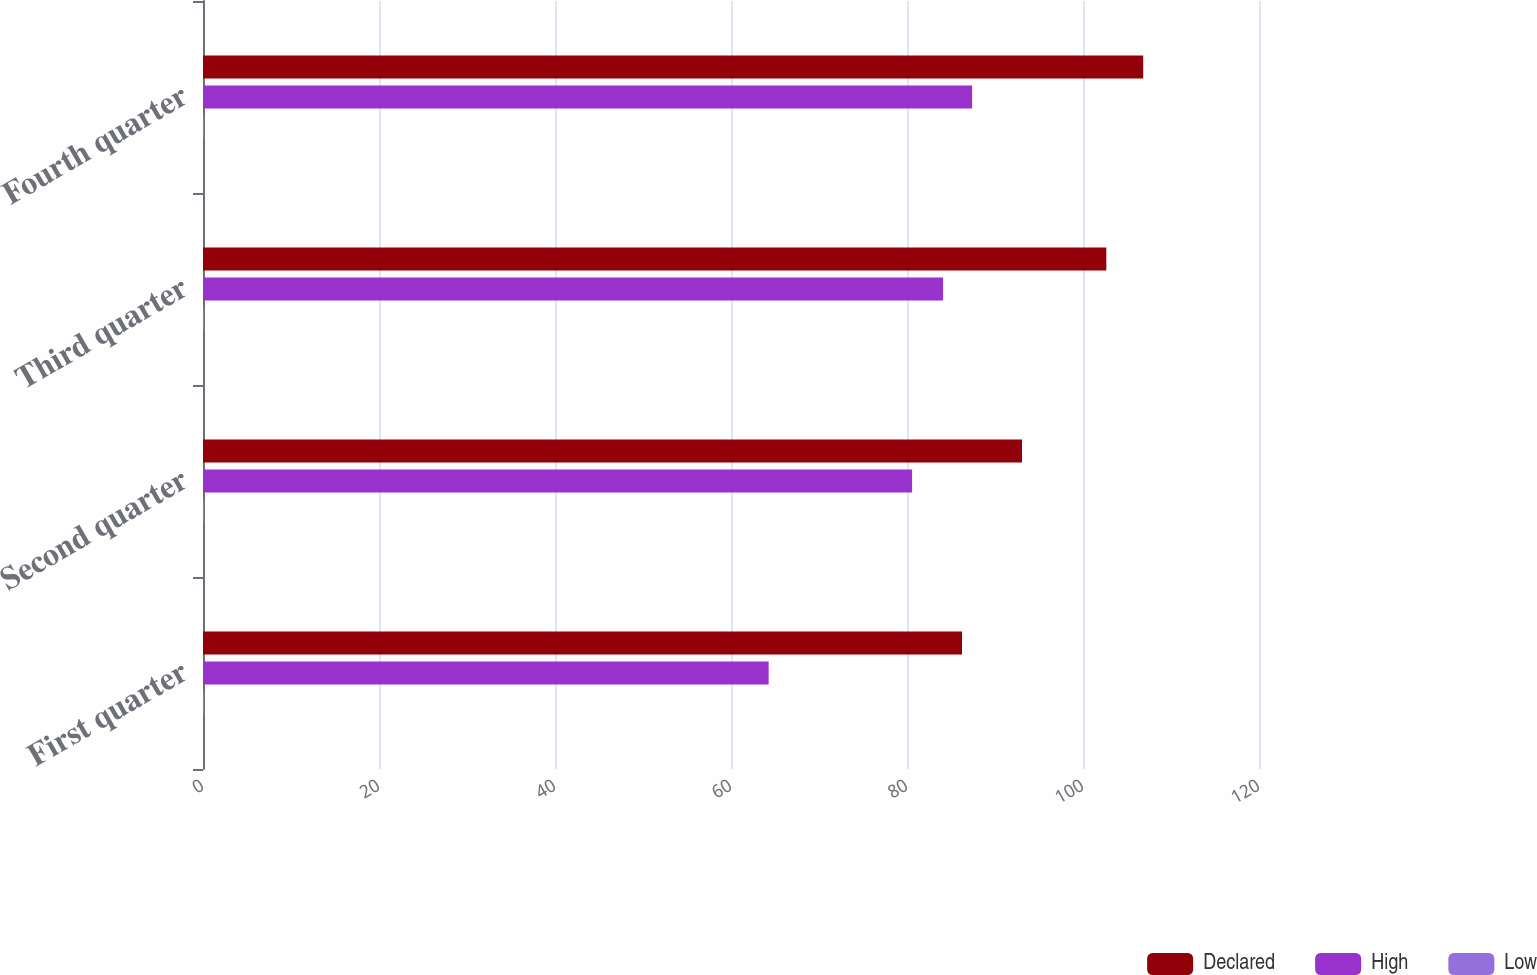Convert chart. <chart><loc_0><loc_0><loc_500><loc_500><stacked_bar_chart><ecel><fcel>First quarter<fcel>Second quarter<fcel>Third quarter<fcel>Fourth quarter<nl><fcel>Declared<fcel>86.25<fcel>93.07<fcel>102.65<fcel>106.84<nl><fcel>High<fcel>64.28<fcel>80.58<fcel>84.1<fcel>87.4<nl><fcel>Low<fcel>0.1<fcel>0.1<fcel>0.1<fcel>0.1<nl></chart> 